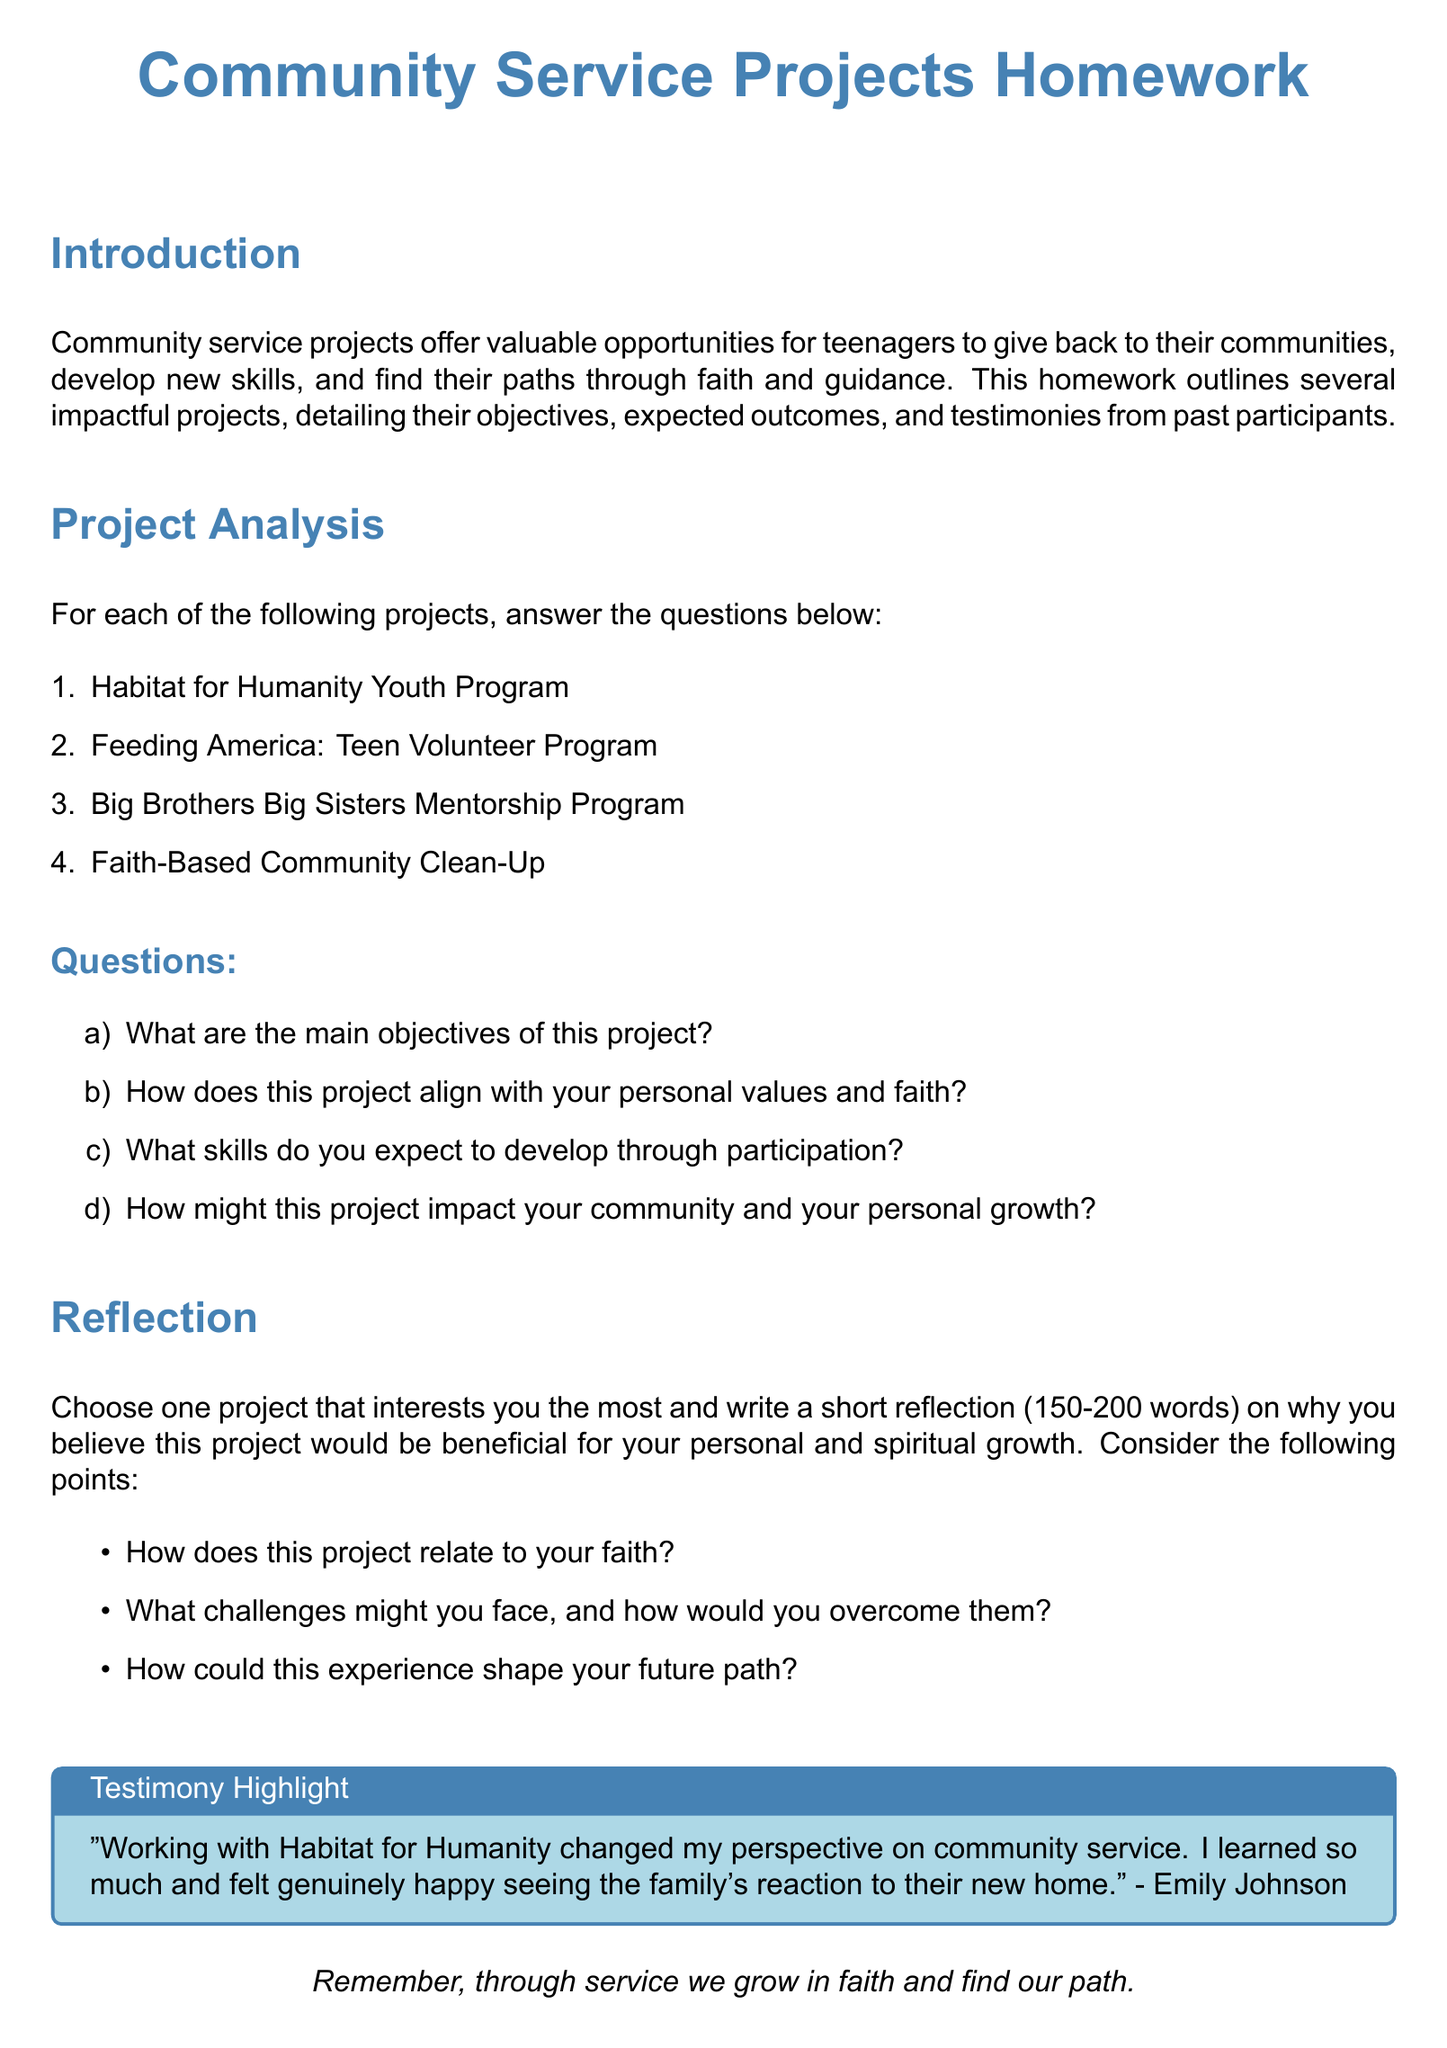What is the title of the homework document? The title of the homework document is prominently displayed at the top of the document.
Answer: Community Service Projects Homework How many community service projects are listed? The document lists a total of four community service projects for analysis.
Answer: 4 What is one of the projects mentioned in the document? The document details several projects, and one of them can be found in the project analysis section.
Answer: Habitat for Humanity Youth Program What is the expected word count for the reflection section? The reflection section specifies a range for the word count that participants should adhere to.
Answer: 150-200 words Which color is used for the titles in the document? The color used for titles is defined at the beginning of the document and applied throughout.
Answer: faithblue What is included in the testimony highlight box? The testimony highlight includes a quote from a past participant about their experience.
Answer: "Working with Habitat for Humanity changed my perspective on community service..." What aspects are suggested for consideration in the reflection? The reflection prompts outline specific points participants should address regarding their chosen project.
Answer: Faith, challenges, future path What is the main purpose of community service projects according to the document? The purpose of community service projects is outlined in the introduction section, summarizing their general intention.
Answer: Give back to their communities 